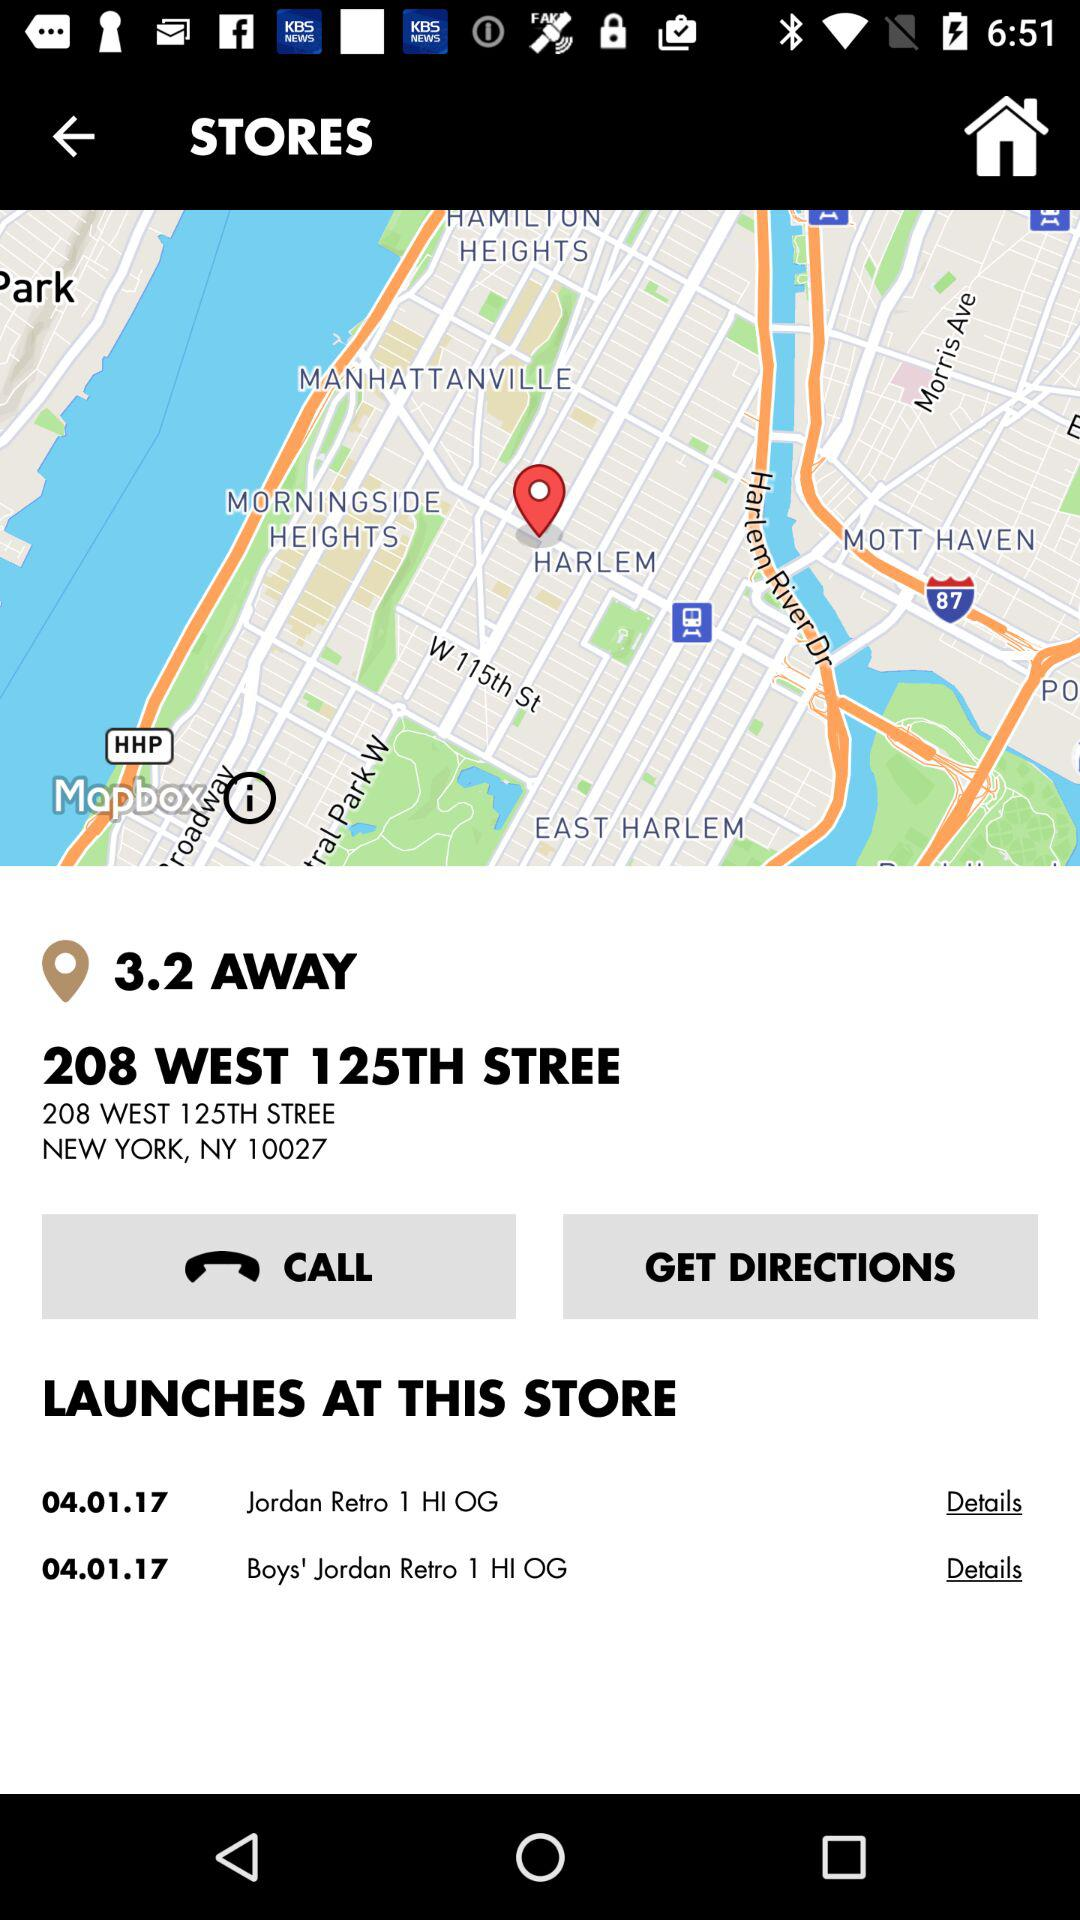What is the date of launch? The date of launch is April 1, 2017. 